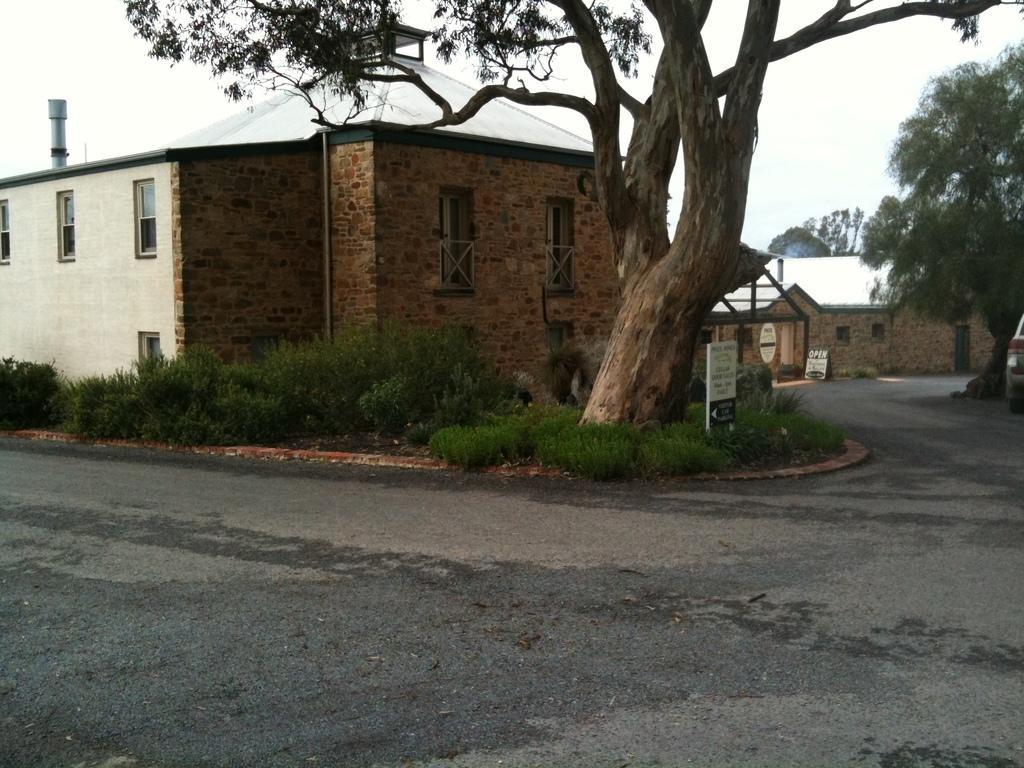Could you give a brief overview of what you see in this image? In this picture there is a road in the front. Behind there is a brown and white color shade house and a huge tree. 